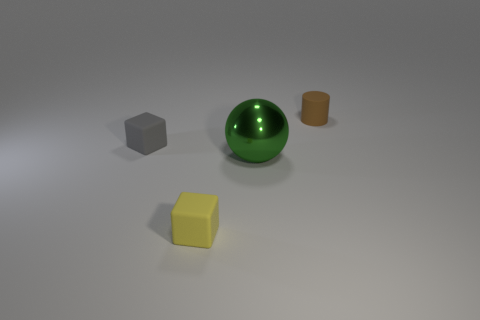There is a brown object that is the same material as the small yellow object; what shape is it?
Provide a succinct answer. Cylinder. Is the shape of the small matte thing in front of the big green thing the same as  the gray rubber object?
Keep it short and to the point. Yes. There is a green shiny thing that is in front of the tiny rubber block on the left side of the yellow block; what is its size?
Your answer should be very brief. Large. What is the color of the small cylinder that is made of the same material as the small gray thing?
Offer a very short reply. Brown. How many yellow blocks have the same size as the cylinder?
Provide a short and direct response. 1. How many green things are either rubber cubes or large metal spheres?
Make the answer very short. 1. How many objects are either purple blocks or rubber objects that are in front of the big green object?
Make the answer very short. 1. There is a thing that is right of the green shiny sphere; what is it made of?
Provide a short and direct response. Rubber. There is a gray rubber object that is the same size as the yellow matte object; what is its shape?
Ensure brevity in your answer.  Cube. Are there any other tiny things of the same shape as the brown object?
Your answer should be very brief. No. 